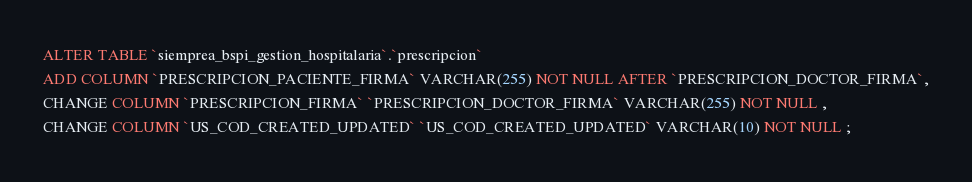<code> <loc_0><loc_0><loc_500><loc_500><_SQL_>ALTER TABLE `siemprea_bspi_gestion_hospitalaria`.`prescripcion` 
ADD COLUMN `PRESCRIPCION_PACIENTE_FIRMA` VARCHAR(255) NOT NULL AFTER `PRESCRIPCION_DOCTOR_FIRMA`,
CHANGE COLUMN `PRESCRIPCION_FIRMA` `PRESCRIPCION_DOCTOR_FIRMA` VARCHAR(255) NOT NULL ,
CHANGE COLUMN `US_COD_CREATED_UPDATED` `US_COD_CREATED_UPDATED` VARCHAR(10) NOT NULL ;
</code> 